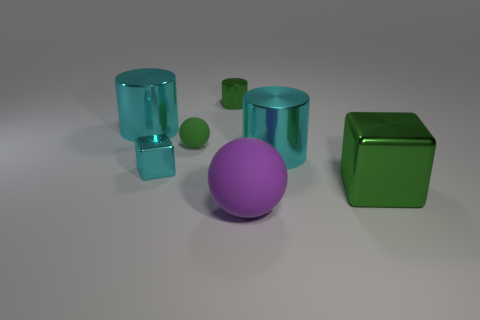Is the color of the rubber thing behind the large shiny block the same as the large cylinder on the right side of the big rubber object?
Provide a short and direct response. No. What number of green objects are large metallic objects or balls?
Ensure brevity in your answer.  2. How many objects have the same size as the green ball?
Offer a very short reply. 2. Does the block on the right side of the big purple rubber ball have the same material as the purple ball?
Your answer should be compact. No. Are there any purple things on the right side of the large cylinder right of the large purple sphere?
Give a very brief answer. No. There is another tiny object that is the same shape as the purple rubber thing; what is it made of?
Make the answer very short. Rubber. Is the number of cyan metal objects on the right side of the purple sphere greater than the number of big matte objects that are on the left side of the tiny cylinder?
Your answer should be very brief. Yes. There is a thing that is the same material as the green ball; what is its shape?
Provide a succinct answer. Sphere. Are there more purple rubber spheres on the left side of the big ball than small green spheres?
Offer a very short reply. No. What number of big things have the same color as the tiny shiny cube?
Ensure brevity in your answer.  2. 